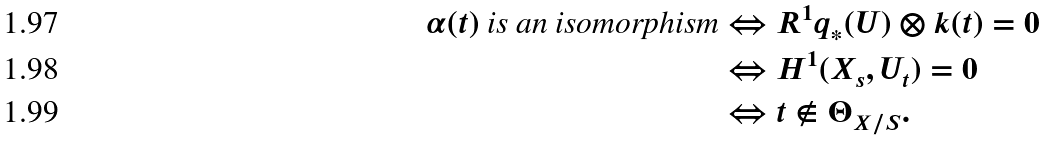<formula> <loc_0><loc_0><loc_500><loc_500>\text {$\alpha(t)$ is an isomorphism} & \Leftrightarrow R ^ { 1 } q _ { * } ( U ) \otimes k ( t ) = 0 \\ & \Leftrightarrow H ^ { 1 } ( X _ { s } , U _ { t } ) = 0 \\ & \Leftrightarrow t \not \in \Theta _ { X / S } .</formula> 